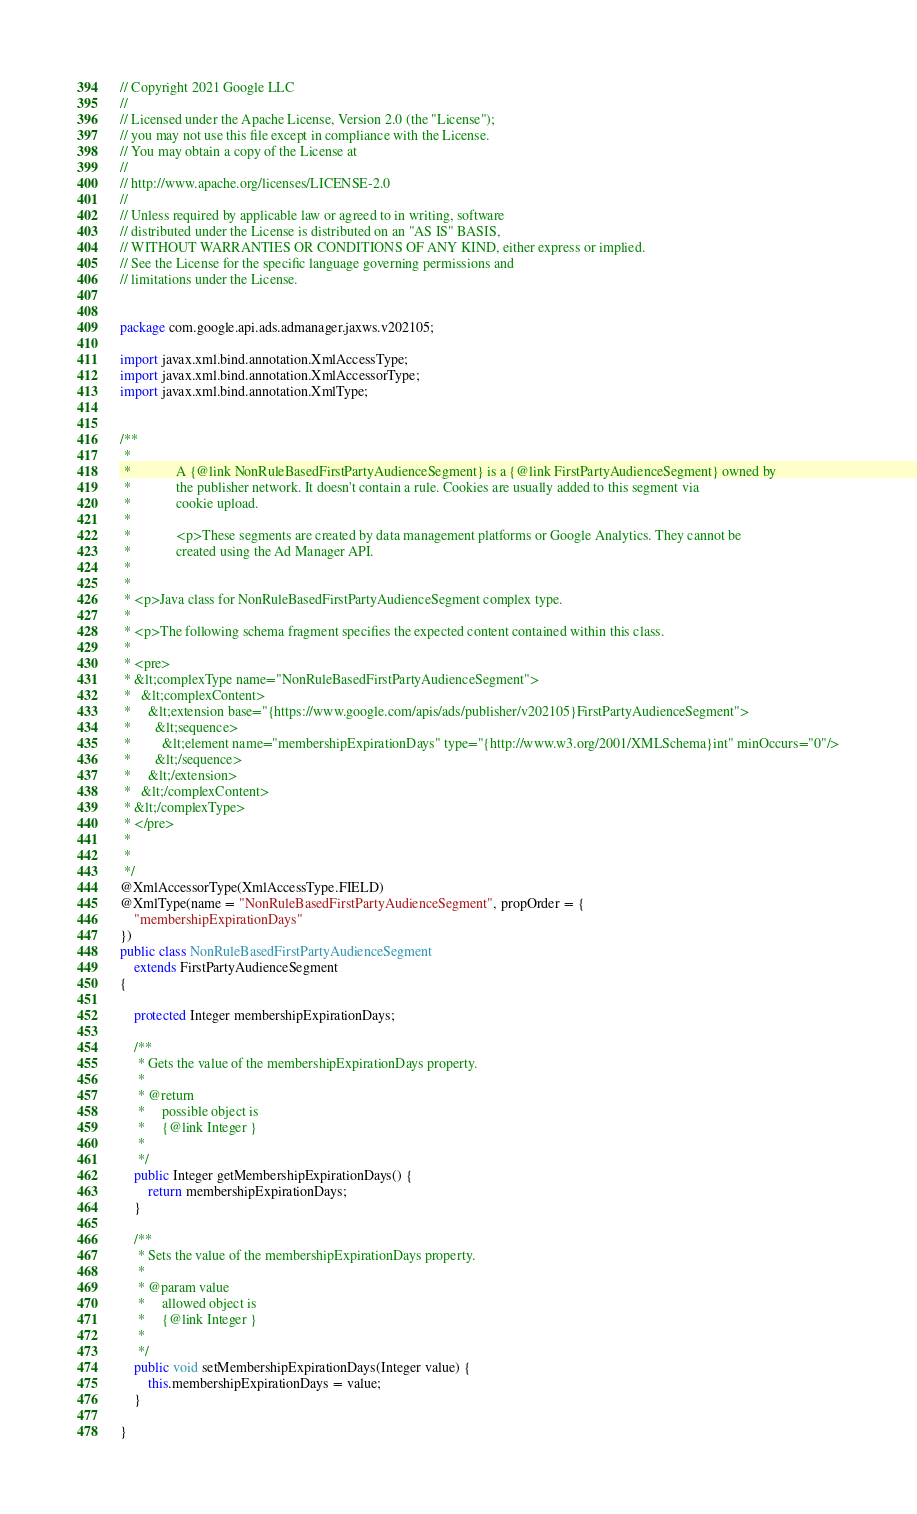Convert code to text. <code><loc_0><loc_0><loc_500><loc_500><_Java_>// Copyright 2021 Google LLC
//
// Licensed under the Apache License, Version 2.0 (the "License");
// you may not use this file except in compliance with the License.
// You may obtain a copy of the License at
//
// http://www.apache.org/licenses/LICENSE-2.0
//
// Unless required by applicable law or agreed to in writing, software
// distributed under the License is distributed on an "AS IS" BASIS,
// WITHOUT WARRANTIES OR CONDITIONS OF ANY KIND, either express or implied.
// See the License for the specific language governing permissions and
// limitations under the License.


package com.google.api.ads.admanager.jaxws.v202105;

import javax.xml.bind.annotation.XmlAccessType;
import javax.xml.bind.annotation.XmlAccessorType;
import javax.xml.bind.annotation.XmlType;


/**
 * 
 *             A {@link NonRuleBasedFirstPartyAudienceSegment} is a {@link FirstPartyAudienceSegment} owned by
 *             the publisher network. It doesn't contain a rule. Cookies are usually added to this segment via
 *             cookie upload.
 *             
 *             <p>These segments are created by data management platforms or Google Analytics. They cannot be
 *             created using the Ad Manager API.
 *           
 * 
 * <p>Java class for NonRuleBasedFirstPartyAudienceSegment complex type.
 * 
 * <p>The following schema fragment specifies the expected content contained within this class.
 * 
 * <pre>
 * &lt;complexType name="NonRuleBasedFirstPartyAudienceSegment">
 *   &lt;complexContent>
 *     &lt;extension base="{https://www.google.com/apis/ads/publisher/v202105}FirstPartyAudienceSegment">
 *       &lt;sequence>
 *         &lt;element name="membershipExpirationDays" type="{http://www.w3.org/2001/XMLSchema}int" minOccurs="0"/>
 *       &lt;/sequence>
 *     &lt;/extension>
 *   &lt;/complexContent>
 * &lt;/complexType>
 * </pre>
 * 
 * 
 */
@XmlAccessorType(XmlAccessType.FIELD)
@XmlType(name = "NonRuleBasedFirstPartyAudienceSegment", propOrder = {
    "membershipExpirationDays"
})
public class NonRuleBasedFirstPartyAudienceSegment
    extends FirstPartyAudienceSegment
{

    protected Integer membershipExpirationDays;

    /**
     * Gets the value of the membershipExpirationDays property.
     * 
     * @return
     *     possible object is
     *     {@link Integer }
     *     
     */
    public Integer getMembershipExpirationDays() {
        return membershipExpirationDays;
    }

    /**
     * Sets the value of the membershipExpirationDays property.
     * 
     * @param value
     *     allowed object is
     *     {@link Integer }
     *     
     */
    public void setMembershipExpirationDays(Integer value) {
        this.membershipExpirationDays = value;
    }

}
</code> 